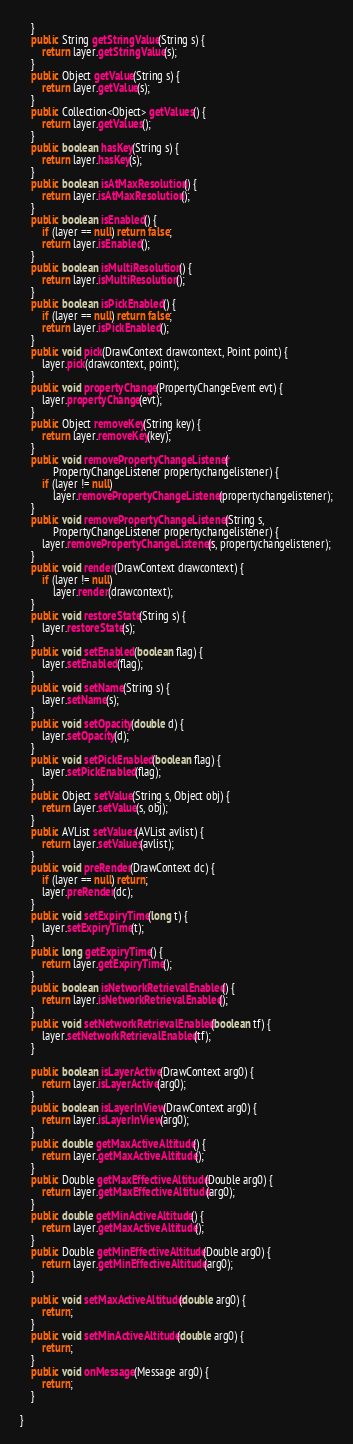Convert code to text. <code><loc_0><loc_0><loc_500><loc_500><_Java_>	}
	public String getStringValue(String s) {
		return layer.getStringValue(s);
	}
	public Object getValue(String s) {
		return layer.getValue(s);
	}
	public Collection<Object> getValues() {
		return layer.getValues();
	}
	public boolean hasKey(String s) {
		return layer.hasKey(s);
	}
	public boolean isAtMaxResolution() {
		return layer.isAtMaxResolution();
	}
	public boolean isEnabled() {
		if (layer == null) return false;
		return layer.isEnabled();
	}
	public boolean isMultiResolution() {
		return layer.isMultiResolution();
	}
	public boolean isPickEnabled() {
		if (layer == null) return false;
		return layer.isPickEnabled();
	}
	public void pick(DrawContext drawcontext, Point point) {
		layer.pick(drawcontext, point);
	}
	public void propertyChange(PropertyChangeEvent evt) {
		layer.propertyChange(evt);
	}
	public Object removeKey(String key) {
		return layer.removeKey(key);
	}
	public void removePropertyChangeListener(
			PropertyChangeListener propertychangelistener) {
		if (layer != null)
			layer.removePropertyChangeListener(propertychangelistener);
	}
	public void removePropertyChangeListener(String s,
			PropertyChangeListener propertychangelistener) {
		layer.removePropertyChangeListener(s, propertychangelistener);
	}
	public void render(DrawContext drawcontext) {
		if (layer != null)
			layer.render(drawcontext);
	}
	public void restoreState(String s) {
		layer.restoreState(s);
	}
	public void setEnabled(boolean flag) {
		layer.setEnabled(flag);
	}
	public void setName(String s) {
		layer.setName(s);
	}
	public void setOpacity(double d) {
		layer.setOpacity(d);
	}
	public void setPickEnabled(boolean flag) {
		layer.setPickEnabled(flag);
	}
	public Object setValue(String s, Object obj) {
		return layer.setValue(s, obj);
	}
	public AVList setValues(AVList avlist) {
		return layer.setValues(avlist);
	}
	public void preRender(DrawContext dc) {
		if (layer == null) return;
		layer.preRender(dc);
	}
	public void setExpiryTime(long t) {
		layer.setExpiryTime(t);
	}
	public long getExpiryTime() {
		return layer.getExpiryTime();
	}
	public boolean isNetworkRetrievalEnabled() {
		return layer.isNetworkRetrievalEnabled();
	}
	public void setNetworkRetrievalEnabled(boolean tf) {
		layer.setNetworkRetrievalEnabled(tf);
	}
	
	public boolean isLayerActive(DrawContext arg0) {
		return layer.isLayerActive(arg0);
	}
	public boolean isLayerInView(DrawContext arg0) {
		return layer.isLayerInView(arg0);	
	}
	public double getMaxActiveAltitude() {
		return layer.getMaxActiveAltitude();
	}
	public Double getMaxEffectiveAltitude(Double arg0) {
		return layer.getMaxEffectiveAltitude(arg0);
	}
	public double getMinActiveAltitude() {
		return layer.getMaxActiveAltitude();
	}
	public Double getMinEffectiveAltitude(Double arg0) {
		return layer.getMinEffectiveAltitude(arg0);
	}

	public void setMaxActiveAltitude(double arg0) {
		return;
	}
	public void setMinActiveAltitude(double arg0) {
		return;
	}
	public void onMessage(Message arg0) {
		return;
	}

}
</code> 